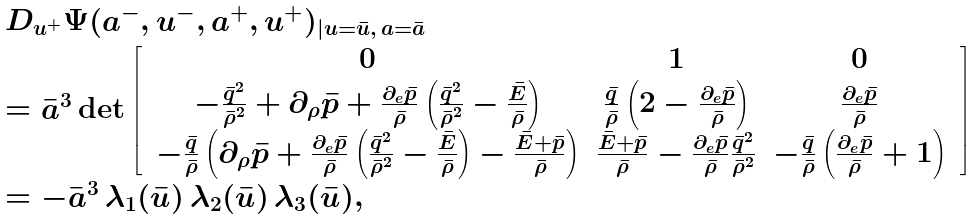<formula> <loc_0><loc_0><loc_500><loc_500>\begin{array} { l } D _ { u ^ { + } } \Psi ( a ^ { - } , u ^ { - } , a ^ { + } , u ^ { + } ) _ { | u = \bar { u } , \, a = \bar { a } } \\ = \bar { a } ^ { 3 } \det \left [ \, \begin{array} { c c c } 0 & 1 & 0 \\ - \frac { \bar { q } ^ { 2 } } { \bar { \rho } ^ { 2 } } + { \partial _ { \rho } \bar { p } } + \frac { \partial _ { e } \bar { p } } { \bar { \rho } } \left ( \frac { \bar { q } ^ { 2 } } { \bar { \rho } ^ { 2 } } - \frac { \bar { E } } { \bar { \rho } } \right ) & \frac { \bar { q } } { \bar { \rho } } \left ( 2 - \frac { \partial _ { e } \bar { p } } { \bar { \rho } } \right ) & \frac { \partial _ { e } \bar { p } } { \bar { \rho } } \\ - \frac { \bar { q } } { \bar { \rho } } \left ( { \partial _ { \rho } \bar { p } } + \frac { \partial _ { e } \bar { p } } { \bar { \rho } } \left ( \frac { \bar { q } ^ { 2 } } { \bar { \rho } ^ { 2 } } - \frac { \bar { E } } { \bar { \rho } } \right ) - \frac { \bar { E } + \bar { p } } { \bar { \rho } } \right ) & \frac { \bar { E } + \bar { p } } { \bar { \rho } } - \frac { \partial _ { e } \bar { p } } { \bar { \rho } } \frac { \bar { q } ^ { 2 } } { \bar { \rho } ^ { 2 } } & - \frac { \bar { q } } { \bar { \rho } } \left ( \frac { \partial _ { e } \bar { p } } { \bar { \rho } } + 1 \right ) \end{array} \, \right ] \, \\ = - \bar { a } ^ { 3 } \, \lambda _ { 1 } ( \bar { u } ) \, \lambda _ { 2 } ( \bar { u } ) \, \lambda _ { 3 } ( \bar { u } ) , \end{array}</formula> 